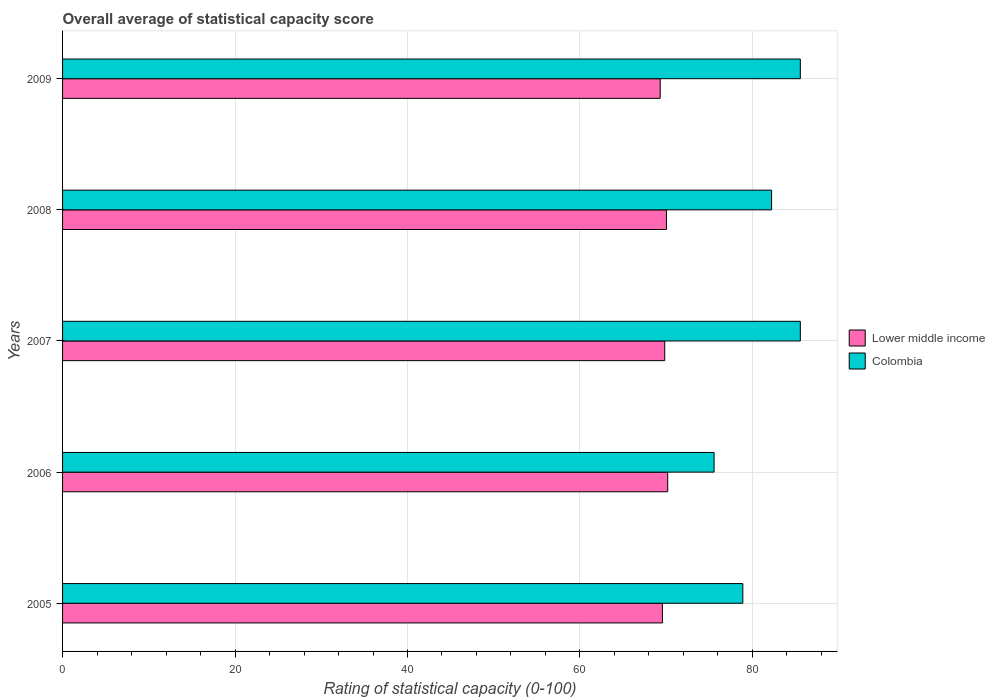How many bars are there on the 2nd tick from the top?
Keep it short and to the point. 2. How many bars are there on the 3rd tick from the bottom?
Offer a terse response. 2. What is the rating of statistical capacity in Lower middle income in 2005?
Your answer should be compact. 69.56. Across all years, what is the maximum rating of statistical capacity in Lower middle income?
Offer a terse response. 70.18. Across all years, what is the minimum rating of statistical capacity in Lower middle income?
Ensure brevity in your answer.  69.31. In which year was the rating of statistical capacity in Lower middle income minimum?
Keep it short and to the point. 2009. What is the total rating of statistical capacity in Colombia in the graph?
Keep it short and to the point. 407.78. What is the difference between the rating of statistical capacity in Colombia in 2009 and the rating of statistical capacity in Lower middle income in 2008?
Your answer should be compact. 15.53. What is the average rating of statistical capacity in Colombia per year?
Provide a succinct answer. 81.56. In the year 2007, what is the difference between the rating of statistical capacity in Lower middle income and rating of statistical capacity in Colombia?
Provide a short and direct response. -15.73. In how many years, is the rating of statistical capacity in Lower middle income greater than 72 ?
Ensure brevity in your answer.  0. What is the ratio of the rating of statistical capacity in Colombia in 2006 to that in 2007?
Offer a very short reply. 0.88. What is the difference between the highest and the second highest rating of statistical capacity in Colombia?
Provide a succinct answer. 0. What is the difference between the highest and the lowest rating of statistical capacity in Colombia?
Ensure brevity in your answer.  10. Is the sum of the rating of statistical capacity in Colombia in 2007 and 2009 greater than the maximum rating of statistical capacity in Lower middle income across all years?
Your answer should be very brief. Yes. What does the 1st bar from the top in 2009 represents?
Provide a short and direct response. Colombia. What does the 2nd bar from the bottom in 2008 represents?
Your answer should be very brief. Colombia. How many bars are there?
Your answer should be compact. 10. How many years are there in the graph?
Make the answer very short. 5. Does the graph contain grids?
Provide a short and direct response. Yes. How many legend labels are there?
Provide a succinct answer. 2. What is the title of the graph?
Your answer should be very brief. Overall average of statistical capacity score. Does "Bulgaria" appear as one of the legend labels in the graph?
Keep it short and to the point. No. What is the label or title of the X-axis?
Your answer should be compact. Rating of statistical capacity (0-100). What is the label or title of the Y-axis?
Offer a very short reply. Years. What is the Rating of statistical capacity (0-100) in Lower middle income in 2005?
Give a very brief answer. 69.56. What is the Rating of statistical capacity (0-100) in Colombia in 2005?
Ensure brevity in your answer.  78.89. What is the Rating of statistical capacity (0-100) in Lower middle income in 2006?
Provide a succinct answer. 70.18. What is the Rating of statistical capacity (0-100) in Colombia in 2006?
Keep it short and to the point. 75.56. What is the Rating of statistical capacity (0-100) of Lower middle income in 2007?
Make the answer very short. 69.83. What is the Rating of statistical capacity (0-100) in Colombia in 2007?
Provide a short and direct response. 85.56. What is the Rating of statistical capacity (0-100) of Lower middle income in 2008?
Offer a very short reply. 70.03. What is the Rating of statistical capacity (0-100) of Colombia in 2008?
Offer a very short reply. 82.22. What is the Rating of statistical capacity (0-100) of Lower middle income in 2009?
Keep it short and to the point. 69.31. What is the Rating of statistical capacity (0-100) of Colombia in 2009?
Your answer should be compact. 85.56. Across all years, what is the maximum Rating of statistical capacity (0-100) in Lower middle income?
Keep it short and to the point. 70.18. Across all years, what is the maximum Rating of statistical capacity (0-100) in Colombia?
Provide a short and direct response. 85.56. Across all years, what is the minimum Rating of statistical capacity (0-100) in Lower middle income?
Offer a terse response. 69.31. Across all years, what is the minimum Rating of statistical capacity (0-100) of Colombia?
Make the answer very short. 75.56. What is the total Rating of statistical capacity (0-100) in Lower middle income in the graph?
Keep it short and to the point. 348.9. What is the total Rating of statistical capacity (0-100) in Colombia in the graph?
Keep it short and to the point. 407.78. What is the difference between the Rating of statistical capacity (0-100) of Lower middle income in 2005 and that in 2006?
Offer a terse response. -0.61. What is the difference between the Rating of statistical capacity (0-100) in Colombia in 2005 and that in 2006?
Keep it short and to the point. 3.33. What is the difference between the Rating of statistical capacity (0-100) in Lower middle income in 2005 and that in 2007?
Offer a terse response. -0.27. What is the difference between the Rating of statistical capacity (0-100) in Colombia in 2005 and that in 2007?
Provide a short and direct response. -6.67. What is the difference between the Rating of statistical capacity (0-100) in Lower middle income in 2005 and that in 2008?
Provide a succinct answer. -0.47. What is the difference between the Rating of statistical capacity (0-100) of Colombia in 2005 and that in 2008?
Provide a succinct answer. -3.33. What is the difference between the Rating of statistical capacity (0-100) in Lower middle income in 2005 and that in 2009?
Keep it short and to the point. 0.26. What is the difference between the Rating of statistical capacity (0-100) in Colombia in 2005 and that in 2009?
Your answer should be compact. -6.67. What is the difference between the Rating of statistical capacity (0-100) of Lower middle income in 2006 and that in 2007?
Provide a short and direct response. 0.35. What is the difference between the Rating of statistical capacity (0-100) of Colombia in 2006 and that in 2007?
Your answer should be compact. -10. What is the difference between the Rating of statistical capacity (0-100) of Lower middle income in 2006 and that in 2008?
Offer a terse response. 0.15. What is the difference between the Rating of statistical capacity (0-100) in Colombia in 2006 and that in 2008?
Offer a very short reply. -6.67. What is the difference between the Rating of statistical capacity (0-100) of Lower middle income in 2006 and that in 2009?
Ensure brevity in your answer.  0.87. What is the difference between the Rating of statistical capacity (0-100) of Lower middle income in 2007 and that in 2008?
Your answer should be very brief. -0.2. What is the difference between the Rating of statistical capacity (0-100) in Colombia in 2007 and that in 2008?
Make the answer very short. 3.33. What is the difference between the Rating of statistical capacity (0-100) of Lower middle income in 2007 and that in 2009?
Keep it short and to the point. 0.52. What is the difference between the Rating of statistical capacity (0-100) of Colombia in 2007 and that in 2009?
Your response must be concise. 0. What is the difference between the Rating of statistical capacity (0-100) of Lower middle income in 2008 and that in 2009?
Provide a succinct answer. 0.72. What is the difference between the Rating of statistical capacity (0-100) in Colombia in 2008 and that in 2009?
Your answer should be very brief. -3.33. What is the difference between the Rating of statistical capacity (0-100) in Lower middle income in 2005 and the Rating of statistical capacity (0-100) in Colombia in 2006?
Provide a succinct answer. -5.99. What is the difference between the Rating of statistical capacity (0-100) of Lower middle income in 2005 and the Rating of statistical capacity (0-100) of Colombia in 2007?
Offer a terse response. -15.99. What is the difference between the Rating of statistical capacity (0-100) in Lower middle income in 2005 and the Rating of statistical capacity (0-100) in Colombia in 2008?
Give a very brief answer. -12.66. What is the difference between the Rating of statistical capacity (0-100) of Lower middle income in 2005 and the Rating of statistical capacity (0-100) of Colombia in 2009?
Give a very brief answer. -15.99. What is the difference between the Rating of statistical capacity (0-100) of Lower middle income in 2006 and the Rating of statistical capacity (0-100) of Colombia in 2007?
Offer a terse response. -15.38. What is the difference between the Rating of statistical capacity (0-100) in Lower middle income in 2006 and the Rating of statistical capacity (0-100) in Colombia in 2008?
Ensure brevity in your answer.  -12.05. What is the difference between the Rating of statistical capacity (0-100) of Lower middle income in 2006 and the Rating of statistical capacity (0-100) of Colombia in 2009?
Ensure brevity in your answer.  -15.38. What is the difference between the Rating of statistical capacity (0-100) in Lower middle income in 2007 and the Rating of statistical capacity (0-100) in Colombia in 2008?
Your response must be concise. -12.39. What is the difference between the Rating of statistical capacity (0-100) in Lower middle income in 2007 and the Rating of statistical capacity (0-100) in Colombia in 2009?
Make the answer very short. -15.73. What is the difference between the Rating of statistical capacity (0-100) in Lower middle income in 2008 and the Rating of statistical capacity (0-100) in Colombia in 2009?
Give a very brief answer. -15.53. What is the average Rating of statistical capacity (0-100) of Lower middle income per year?
Offer a very short reply. 69.78. What is the average Rating of statistical capacity (0-100) in Colombia per year?
Provide a short and direct response. 81.56. In the year 2005, what is the difference between the Rating of statistical capacity (0-100) in Lower middle income and Rating of statistical capacity (0-100) in Colombia?
Make the answer very short. -9.33. In the year 2006, what is the difference between the Rating of statistical capacity (0-100) of Lower middle income and Rating of statistical capacity (0-100) of Colombia?
Ensure brevity in your answer.  -5.38. In the year 2007, what is the difference between the Rating of statistical capacity (0-100) in Lower middle income and Rating of statistical capacity (0-100) in Colombia?
Your response must be concise. -15.73. In the year 2008, what is the difference between the Rating of statistical capacity (0-100) in Lower middle income and Rating of statistical capacity (0-100) in Colombia?
Your answer should be very brief. -12.19. In the year 2009, what is the difference between the Rating of statistical capacity (0-100) of Lower middle income and Rating of statistical capacity (0-100) of Colombia?
Offer a very short reply. -16.25. What is the ratio of the Rating of statistical capacity (0-100) in Lower middle income in 2005 to that in 2006?
Your answer should be very brief. 0.99. What is the ratio of the Rating of statistical capacity (0-100) in Colombia in 2005 to that in 2006?
Offer a very short reply. 1.04. What is the ratio of the Rating of statistical capacity (0-100) in Lower middle income in 2005 to that in 2007?
Your answer should be very brief. 1. What is the ratio of the Rating of statistical capacity (0-100) in Colombia in 2005 to that in 2007?
Provide a short and direct response. 0.92. What is the ratio of the Rating of statistical capacity (0-100) of Lower middle income in 2005 to that in 2008?
Your answer should be compact. 0.99. What is the ratio of the Rating of statistical capacity (0-100) of Colombia in 2005 to that in 2008?
Your answer should be compact. 0.96. What is the ratio of the Rating of statistical capacity (0-100) in Colombia in 2005 to that in 2009?
Provide a succinct answer. 0.92. What is the ratio of the Rating of statistical capacity (0-100) in Colombia in 2006 to that in 2007?
Your response must be concise. 0.88. What is the ratio of the Rating of statistical capacity (0-100) in Colombia in 2006 to that in 2008?
Your answer should be compact. 0.92. What is the ratio of the Rating of statistical capacity (0-100) in Lower middle income in 2006 to that in 2009?
Offer a very short reply. 1.01. What is the ratio of the Rating of statistical capacity (0-100) of Colombia in 2006 to that in 2009?
Provide a short and direct response. 0.88. What is the ratio of the Rating of statistical capacity (0-100) of Colombia in 2007 to that in 2008?
Provide a succinct answer. 1.04. What is the ratio of the Rating of statistical capacity (0-100) in Lower middle income in 2007 to that in 2009?
Your answer should be very brief. 1.01. What is the ratio of the Rating of statistical capacity (0-100) in Colombia in 2007 to that in 2009?
Your answer should be compact. 1. What is the ratio of the Rating of statistical capacity (0-100) of Lower middle income in 2008 to that in 2009?
Provide a succinct answer. 1.01. What is the ratio of the Rating of statistical capacity (0-100) in Colombia in 2008 to that in 2009?
Your response must be concise. 0.96. What is the difference between the highest and the second highest Rating of statistical capacity (0-100) in Lower middle income?
Give a very brief answer. 0.15. What is the difference between the highest and the second highest Rating of statistical capacity (0-100) of Colombia?
Keep it short and to the point. 0. What is the difference between the highest and the lowest Rating of statistical capacity (0-100) of Lower middle income?
Offer a very short reply. 0.87. 